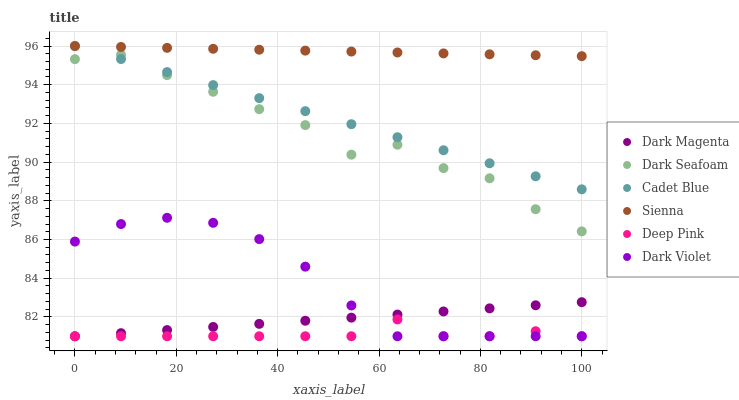Does Deep Pink have the minimum area under the curve?
Answer yes or no. Yes. Does Sienna have the maximum area under the curve?
Answer yes or no. Yes. Does Dark Magenta have the minimum area under the curve?
Answer yes or no. No. Does Dark Magenta have the maximum area under the curve?
Answer yes or no. No. Is Sienna the smoothest?
Answer yes or no. Yes. Is Dark Seafoam the roughest?
Answer yes or no. Yes. Is Dark Magenta the smoothest?
Answer yes or no. No. Is Dark Magenta the roughest?
Answer yes or no. No. Does Dark Magenta have the lowest value?
Answer yes or no. Yes. Does Sienna have the lowest value?
Answer yes or no. No. Does Sienna have the highest value?
Answer yes or no. Yes. Does Dark Magenta have the highest value?
Answer yes or no. No. Is Dark Violet less than Sienna?
Answer yes or no. Yes. Is Cadet Blue greater than Dark Violet?
Answer yes or no. Yes. Does Sienna intersect Cadet Blue?
Answer yes or no. Yes. Is Sienna less than Cadet Blue?
Answer yes or no. No. Is Sienna greater than Cadet Blue?
Answer yes or no. No. Does Dark Violet intersect Sienna?
Answer yes or no. No. 